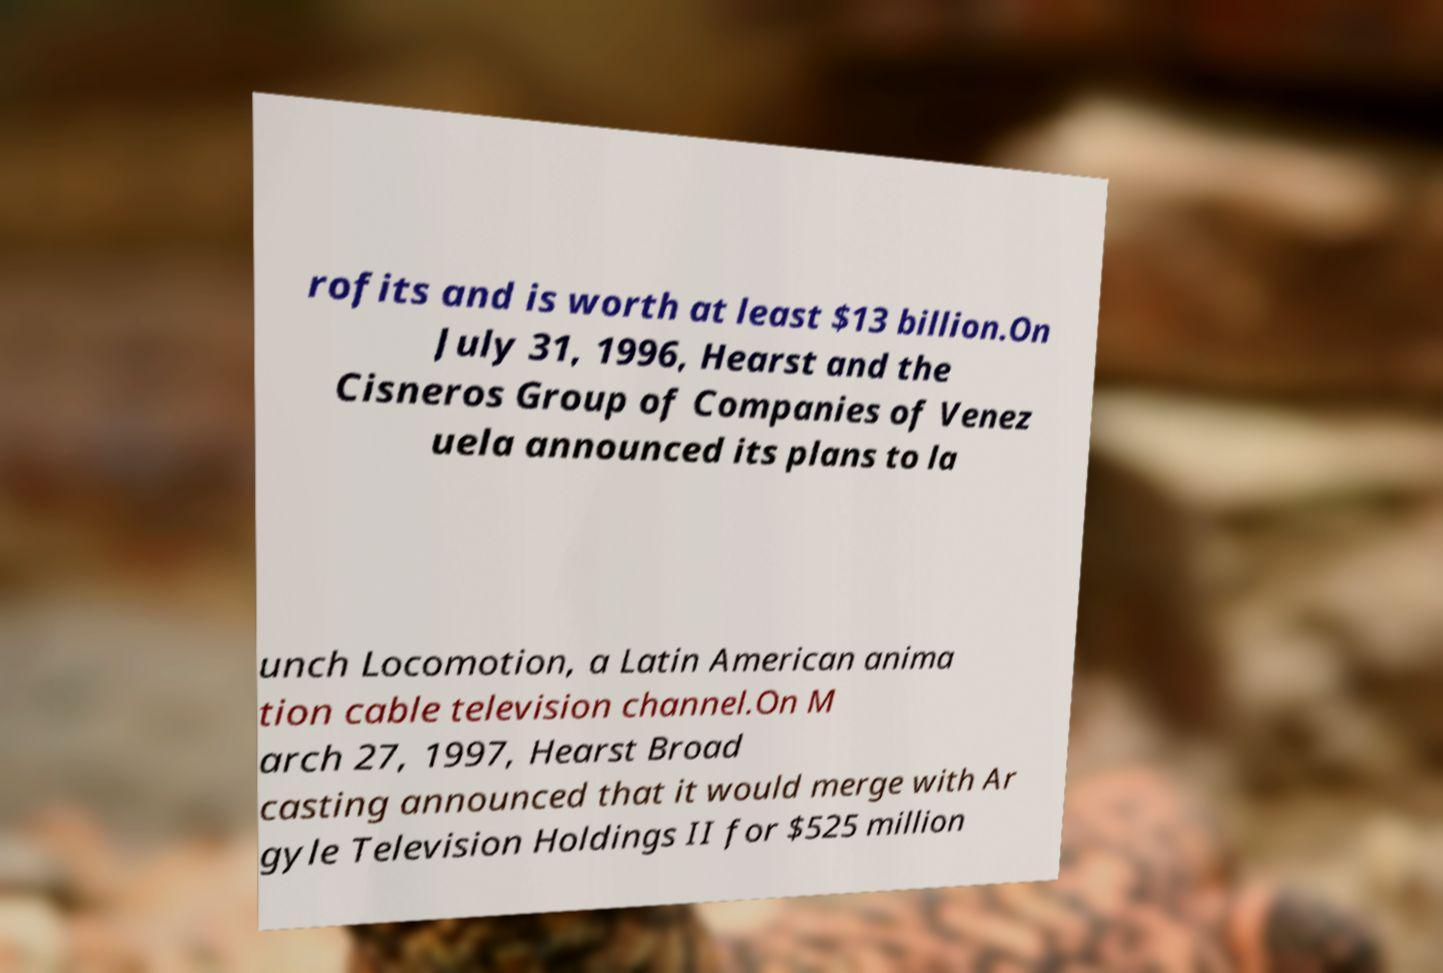There's text embedded in this image that I need extracted. Can you transcribe it verbatim? rofits and is worth at least $13 billion.On July 31, 1996, Hearst and the Cisneros Group of Companies of Venez uela announced its plans to la unch Locomotion, a Latin American anima tion cable television channel.On M arch 27, 1997, Hearst Broad casting announced that it would merge with Ar gyle Television Holdings II for $525 million 